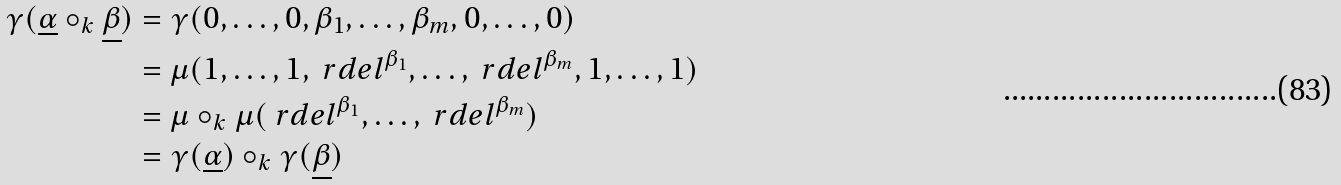<formula> <loc_0><loc_0><loc_500><loc_500>\gamma ( \underline { \alpha } \circ _ { k } \underline { \beta } ) & = \gamma ( 0 , \dots , 0 , \beta _ { 1 } , \dots , \beta _ { m } , 0 , \dots , 0 ) \\ & = \mu ( 1 , \dots , 1 , \ r d e l ^ { \beta _ { 1 } } , \dots , \ r d e l ^ { \beta _ { m } } , 1 , \dots , 1 ) \\ & = \mu \circ _ { k } \mu ( \ r d e l ^ { \beta _ { 1 } } , \dots , \ r d e l ^ { \beta _ { m } } ) \\ & = \gamma ( \underline { \alpha } ) \circ _ { k } \gamma ( \underline { \beta } ) \\</formula> 